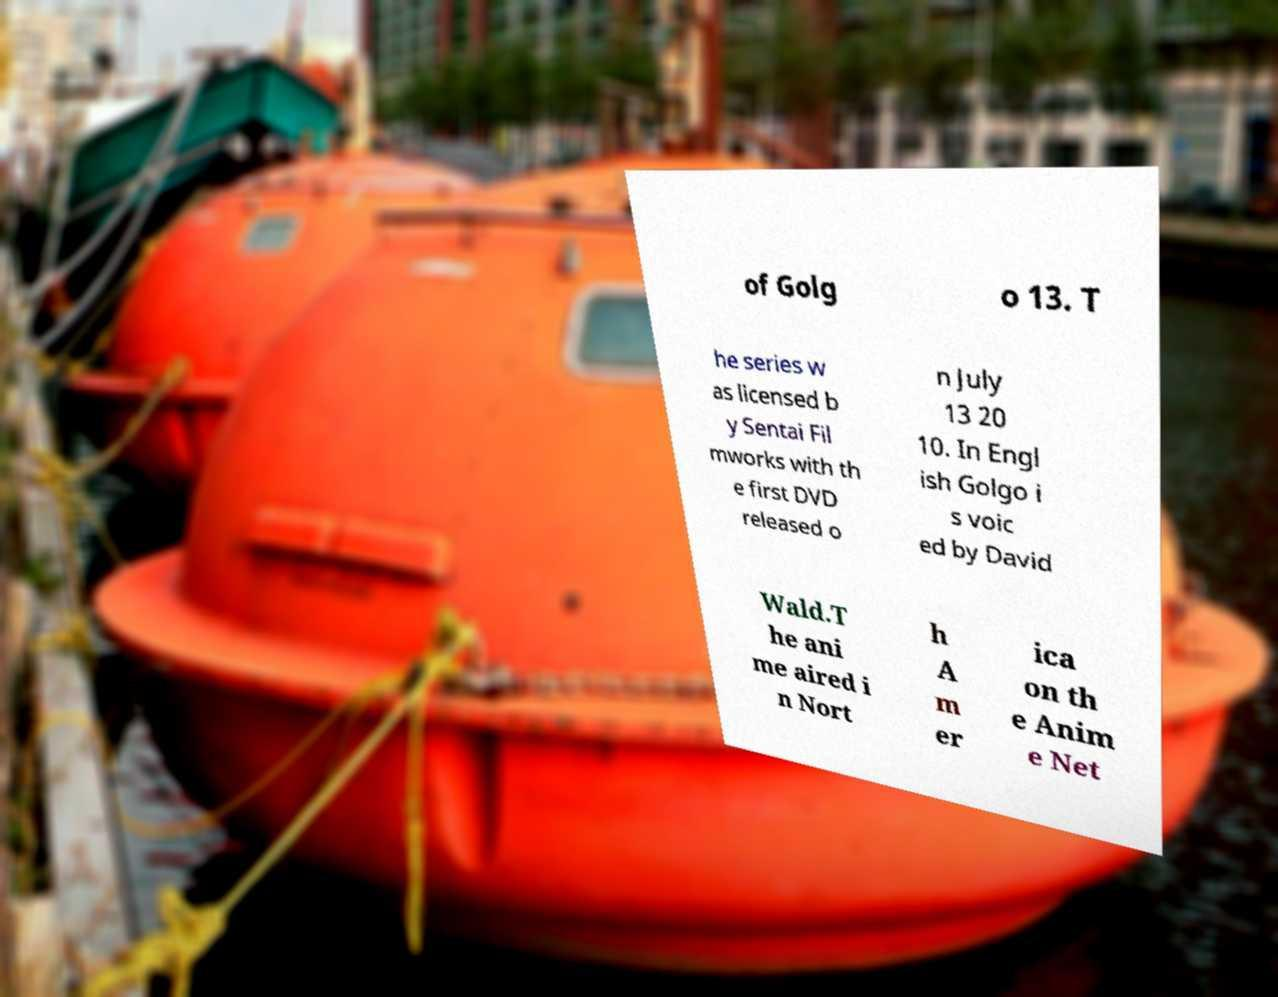Can you read and provide the text displayed in the image?This photo seems to have some interesting text. Can you extract and type it out for me? of Golg o 13. T he series w as licensed b y Sentai Fil mworks with th e first DVD released o n July 13 20 10. In Engl ish Golgo i s voic ed by David Wald.T he ani me aired i n Nort h A m er ica on th e Anim e Net 